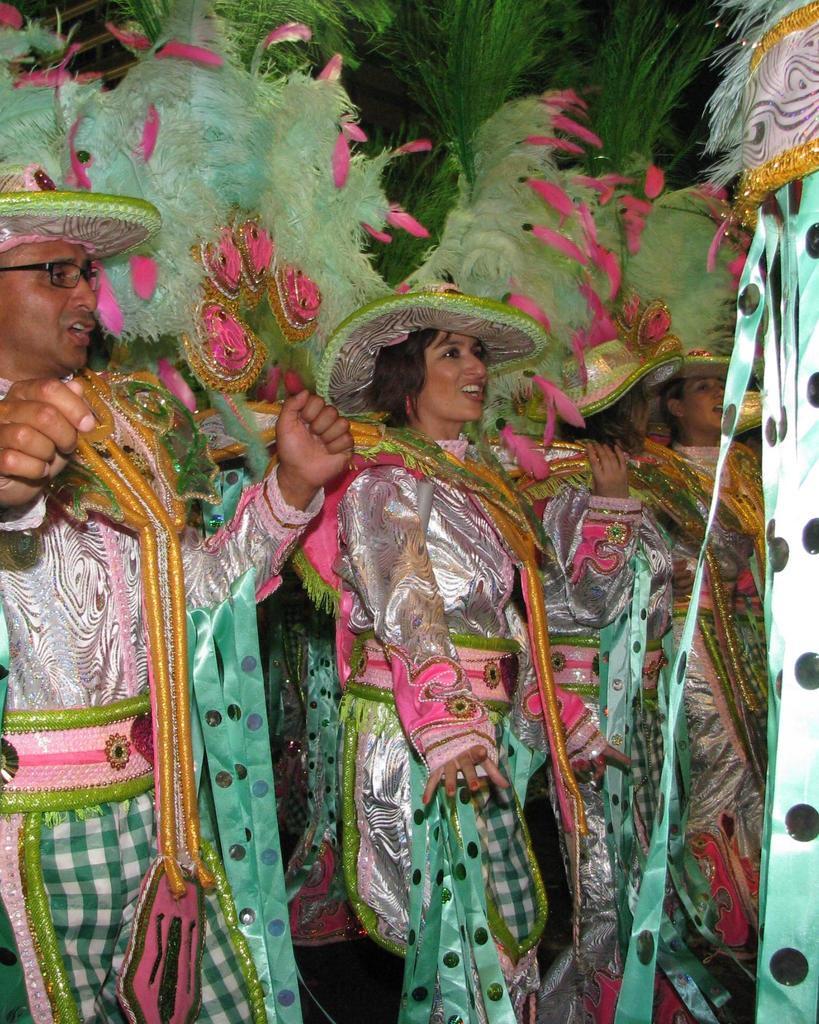Can you describe this image briefly? In this picture I can observe some people wearing green color costumes. There are men and women in this picture. 